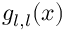Convert formula to latex. <formula><loc_0><loc_0><loc_500><loc_500>g _ { l , l } ( x )</formula> 